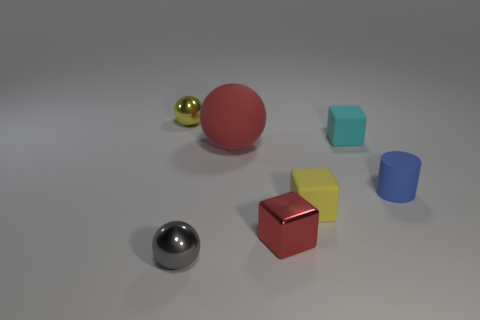Add 2 small blue cylinders. How many objects exist? 9 Subtract all cubes. How many objects are left? 4 Subtract all small gray balls. Subtract all tiny yellow objects. How many objects are left? 4 Add 5 cyan blocks. How many cyan blocks are left? 6 Add 4 rubber cylinders. How many rubber cylinders exist? 5 Subtract 0 yellow cylinders. How many objects are left? 7 